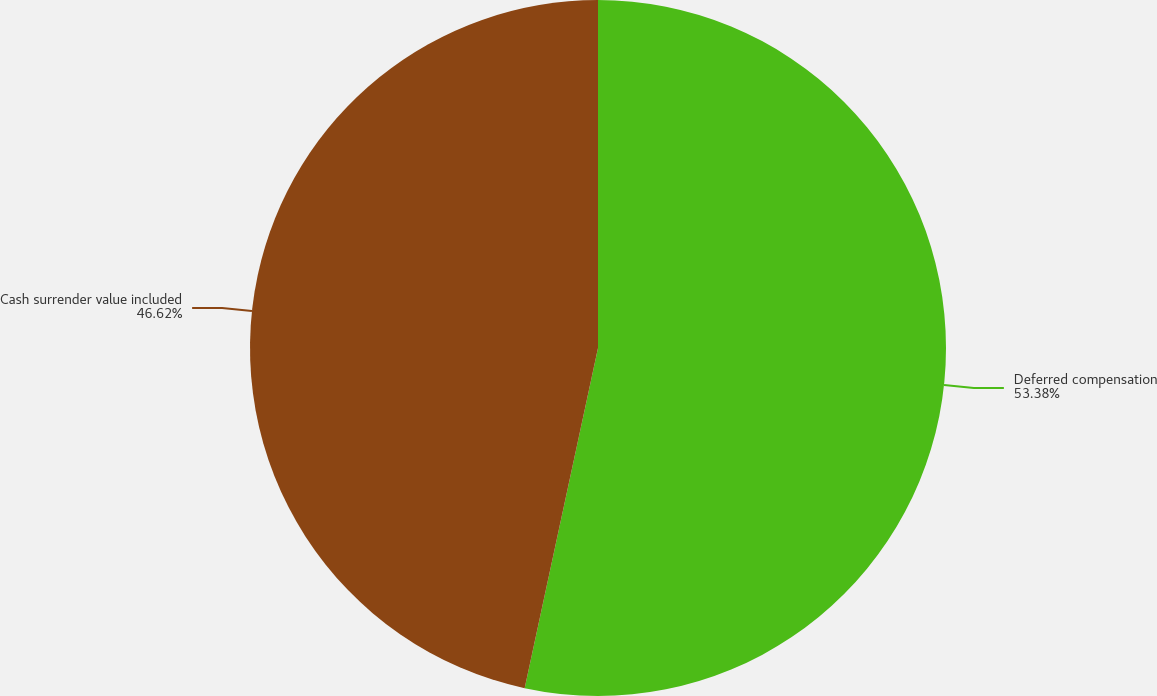<chart> <loc_0><loc_0><loc_500><loc_500><pie_chart><fcel>Deferred compensation<fcel>Cash surrender value included<nl><fcel>53.38%<fcel>46.62%<nl></chart> 